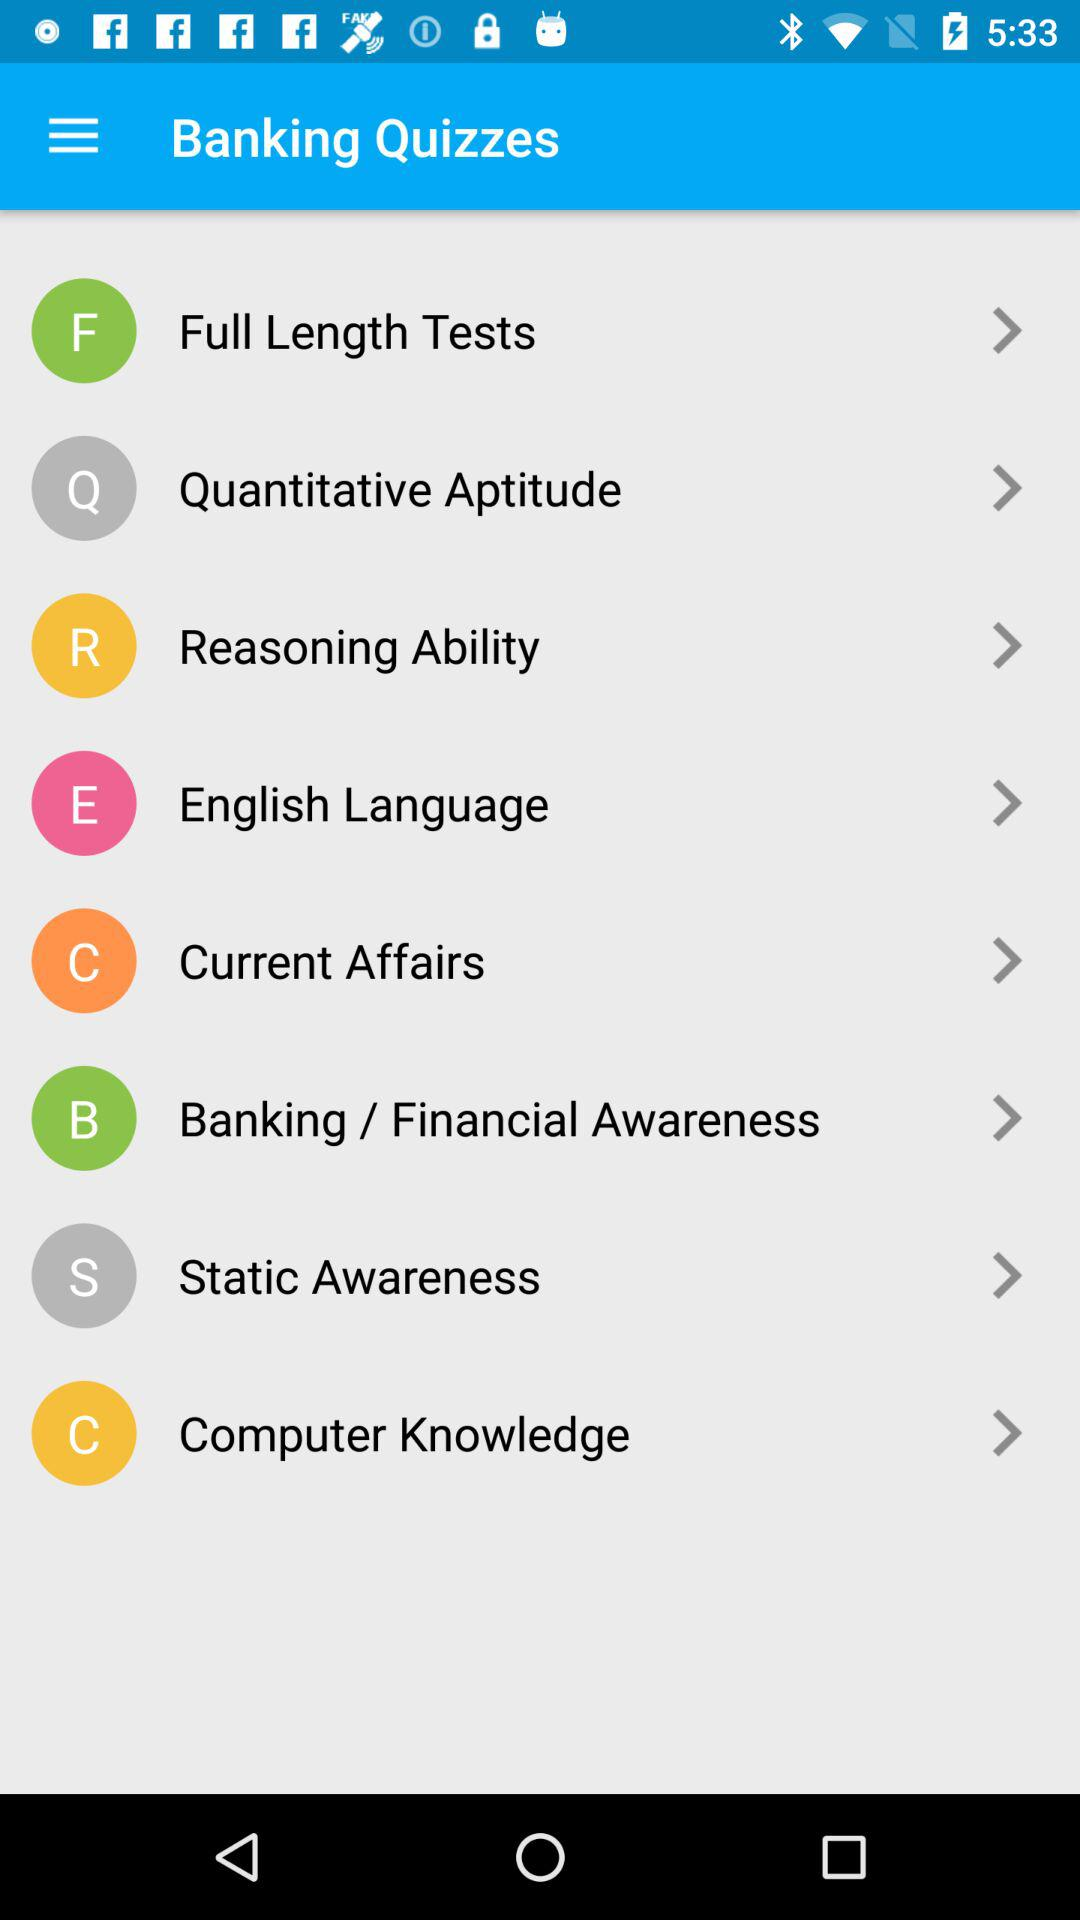How many quiz categories are there?
Answer the question using a single word or phrase. 8 